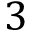Convert formula to latex. <formula><loc_0><loc_0><loc_500><loc_500>3</formula> 